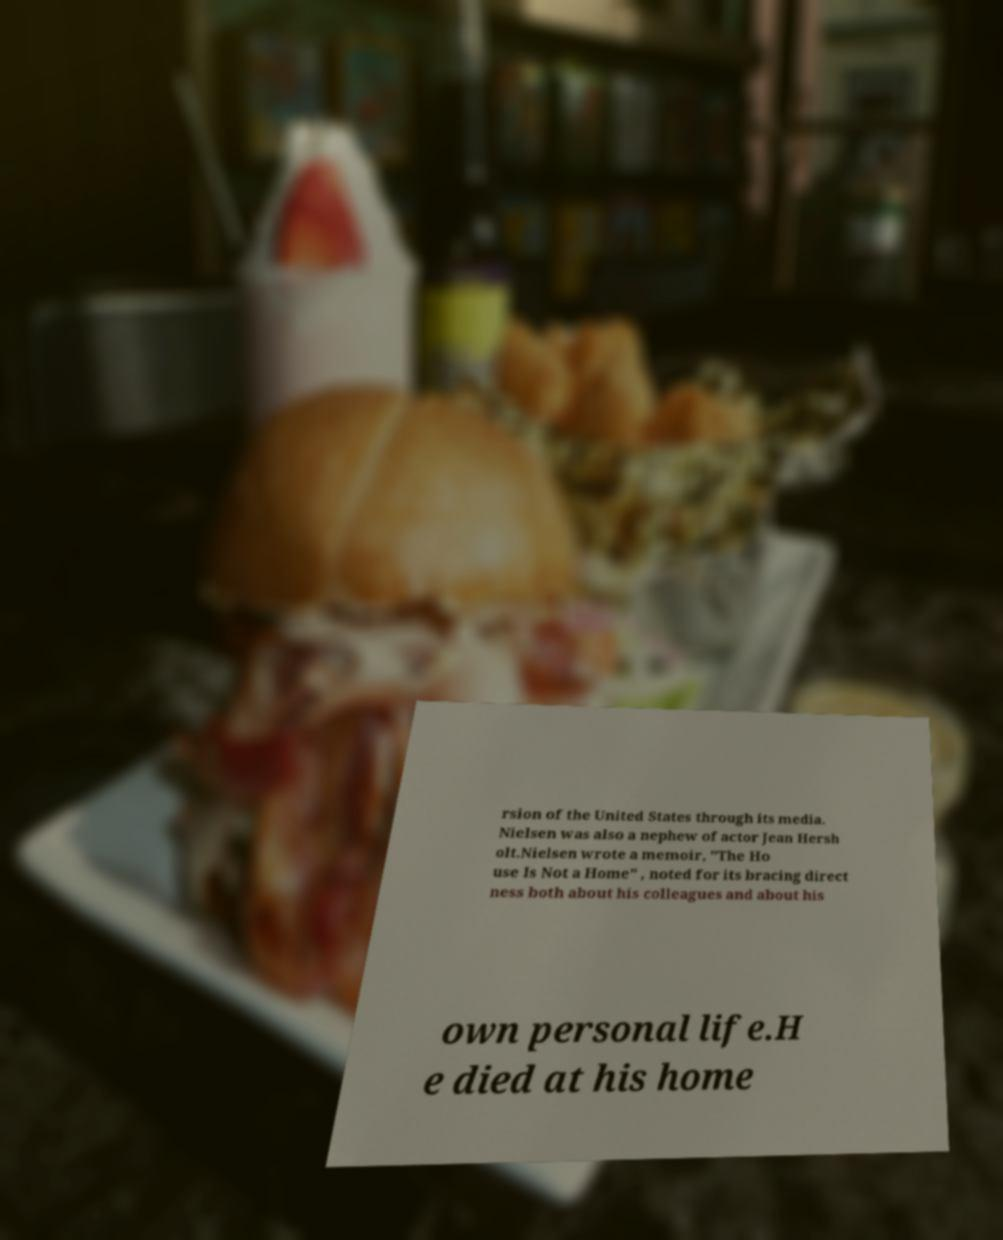What messages or text are displayed in this image? I need them in a readable, typed format. rsion of the United States through its media. Nielsen was also a nephew of actor Jean Hersh olt.Nielsen wrote a memoir, "The Ho use Is Not a Home" , noted for its bracing direct ness both about his colleagues and about his own personal life.H e died at his home 